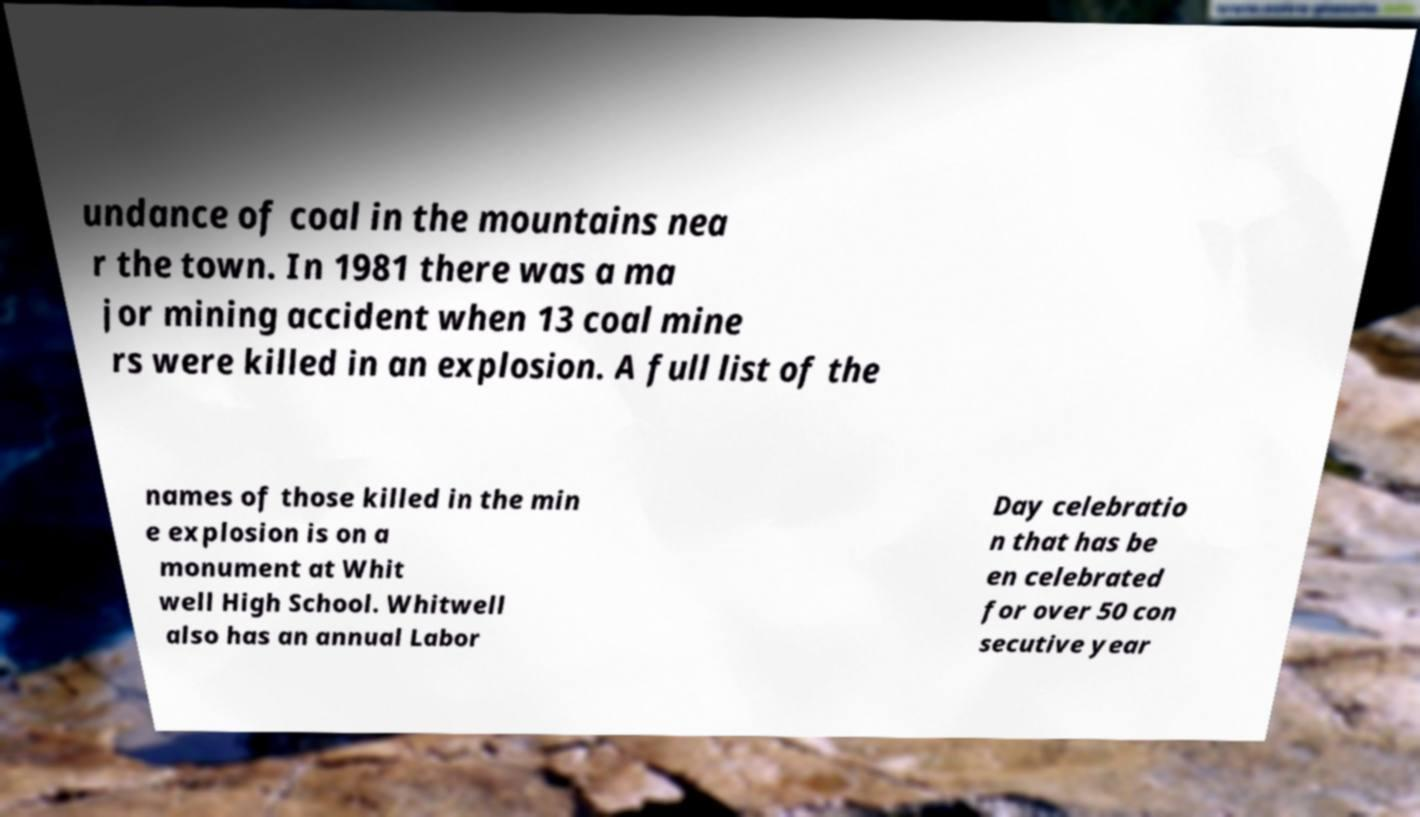Can you read and provide the text displayed in the image?This photo seems to have some interesting text. Can you extract and type it out for me? undance of coal in the mountains nea r the town. In 1981 there was a ma jor mining accident when 13 coal mine rs were killed in an explosion. A full list of the names of those killed in the min e explosion is on a monument at Whit well High School. Whitwell also has an annual Labor Day celebratio n that has be en celebrated for over 50 con secutive year 